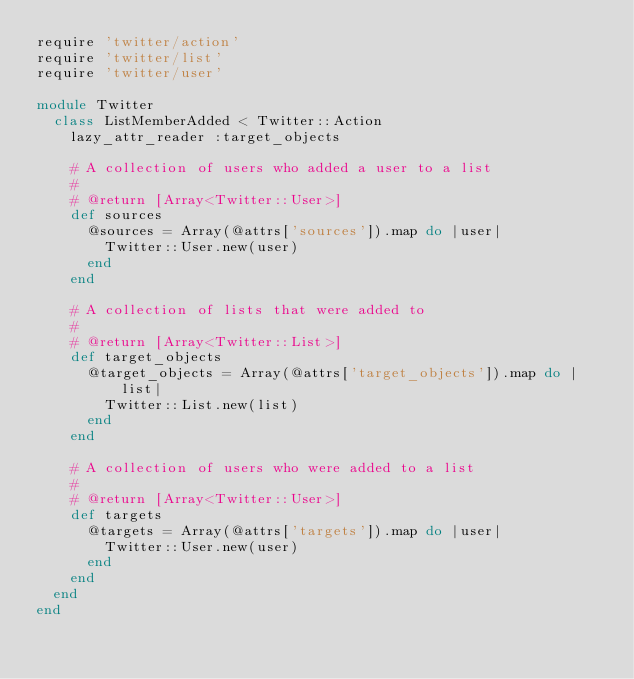<code> <loc_0><loc_0><loc_500><loc_500><_Ruby_>require 'twitter/action'
require 'twitter/list'
require 'twitter/user'

module Twitter
  class ListMemberAdded < Twitter::Action
    lazy_attr_reader :target_objects

    # A collection of users who added a user to a list
    #
    # @return [Array<Twitter::User>]
    def sources
      @sources = Array(@attrs['sources']).map do |user|
        Twitter::User.new(user)
      end
    end

    # A collection of lists that were added to
    #
    # @return [Array<Twitter::List>]
    def target_objects
      @target_objects = Array(@attrs['target_objects']).map do |list|
        Twitter::List.new(list)
      end
    end

    # A collection of users who were added to a list
    #
    # @return [Array<Twitter::User>]
    def targets
      @targets = Array(@attrs['targets']).map do |user|
        Twitter::User.new(user)
      end
    end
  end
end
</code> 